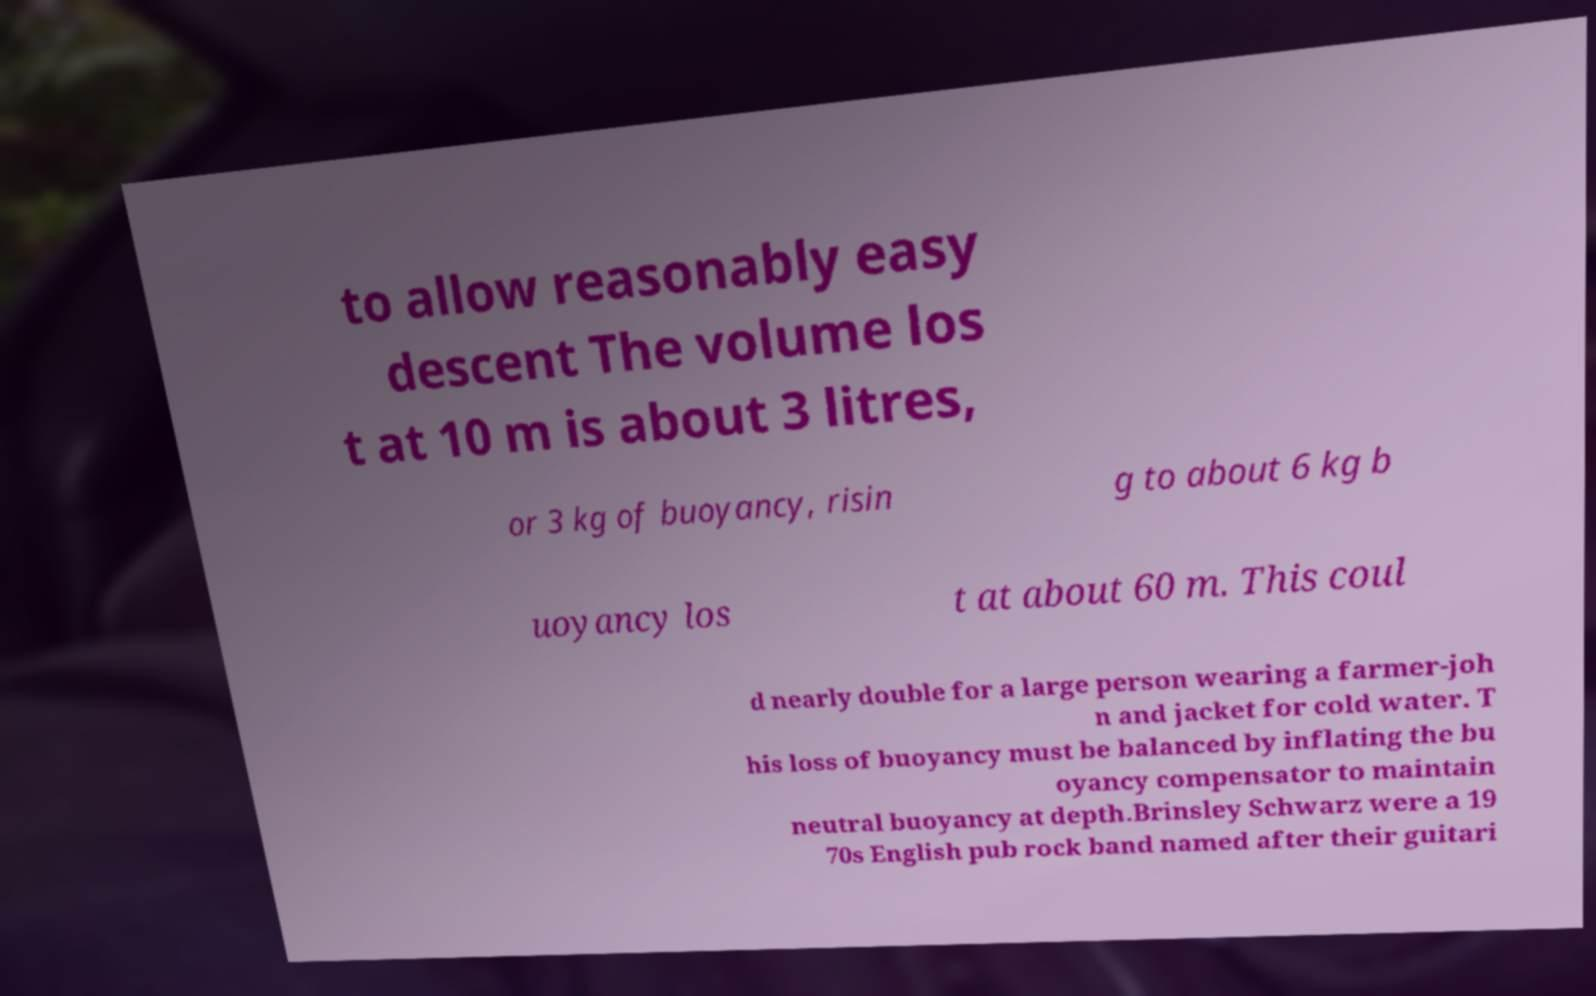Please identify and transcribe the text found in this image. to allow reasonably easy descent The volume los t at 10 m is about 3 litres, or 3 kg of buoyancy, risin g to about 6 kg b uoyancy los t at about 60 m. This coul d nearly double for a large person wearing a farmer-joh n and jacket for cold water. T his loss of buoyancy must be balanced by inflating the bu oyancy compensator to maintain neutral buoyancy at depth.Brinsley Schwarz were a 19 70s English pub rock band named after their guitari 